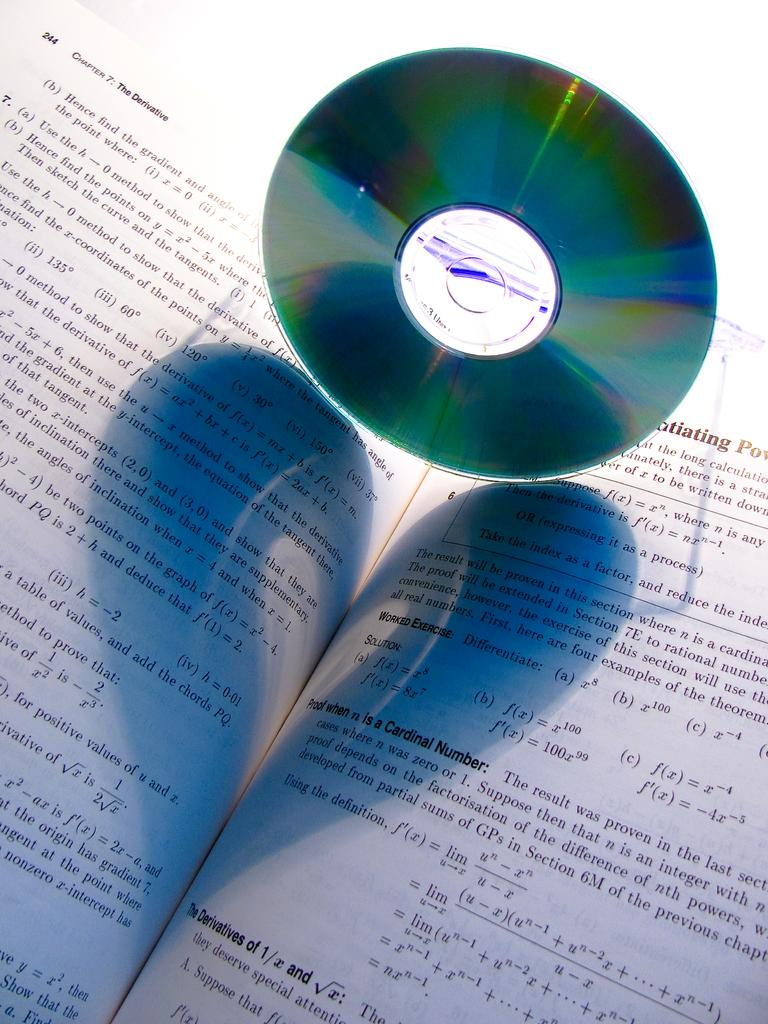Provide a one-sentence caption for the provided image. A CD is resting on a math book that is open to chapter 7. 